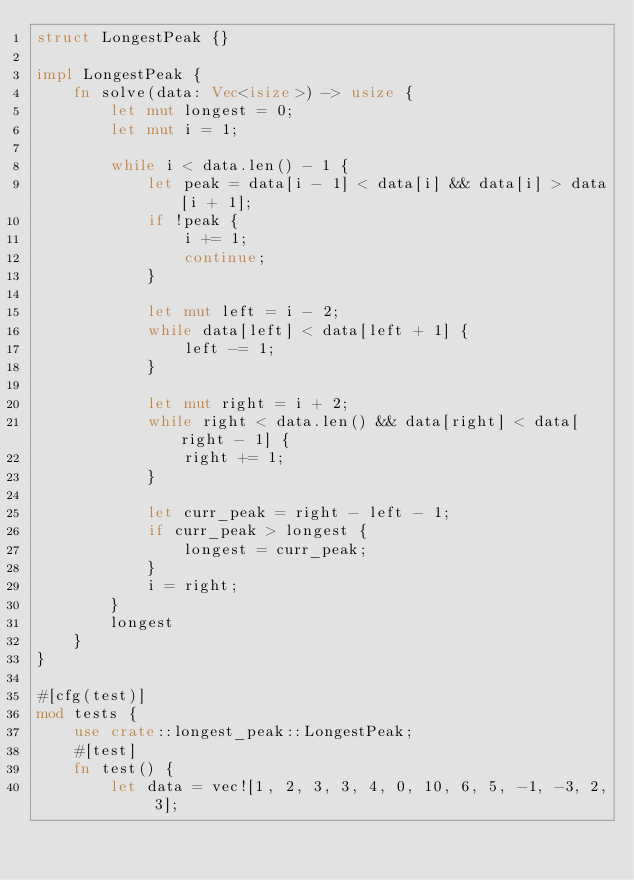<code> <loc_0><loc_0><loc_500><loc_500><_Rust_>struct LongestPeak {}

impl LongestPeak {
    fn solve(data: Vec<isize>) -> usize {
        let mut longest = 0;
        let mut i = 1;

        while i < data.len() - 1 {
            let peak = data[i - 1] < data[i] && data[i] > data[i + 1];
            if !peak {
                i += 1;
                continue;
            }

            let mut left = i - 2;
            while data[left] < data[left + 1] {
                left -= 1;
            }

            let mut right = i + 2;
            while right < data.len() && data[right] < data[right - 1] {
                right += 1;
            }

            let curr_peak = right - left - 1;
            if curr_peak > longest {
                longest = curr_peak;
            }
            i = right;
        }
        longest
    }
}

#[cfg(test)]
mod tests {
    use crate::longest_peak::LongestPeak;
    #[test]
    fn test() {
        let data = vec![1, 2, 3, 3, 4, 0, 10, 6, 5, -1, -3, 2, 3];</code> 